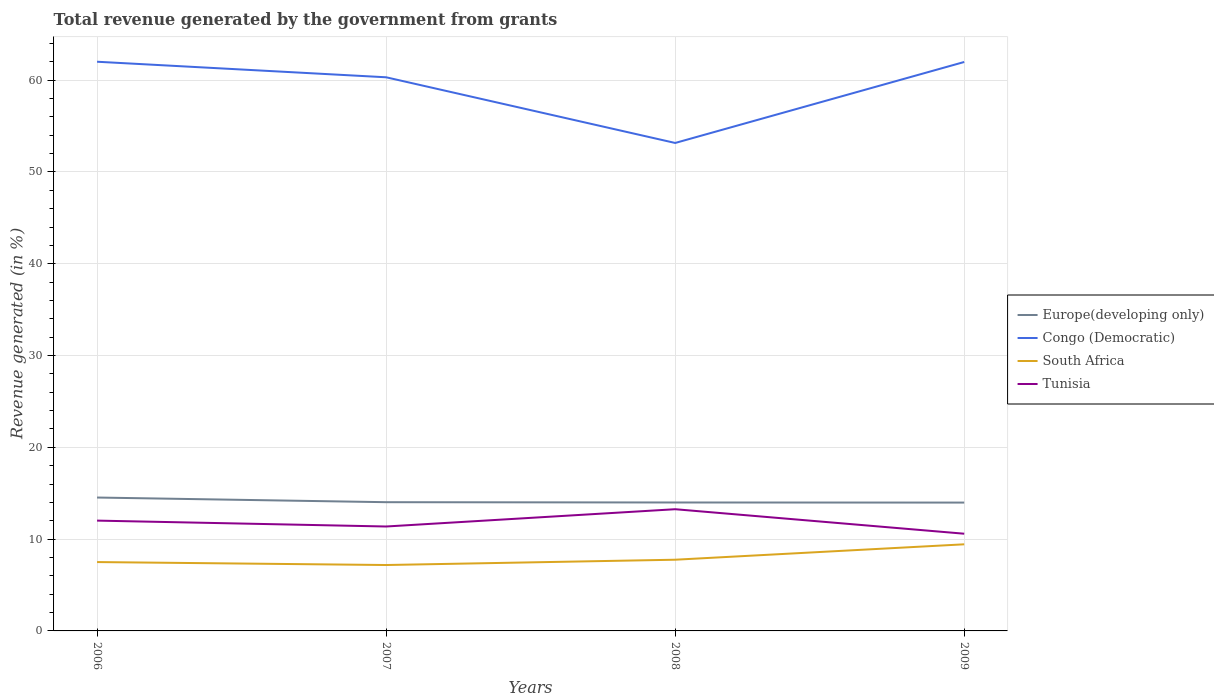How many different coloured lines are there?
Keep it short and to the point. 4. Does the line corresponding to Tunisia intersect with the line corresponding to South Africa?
Provide a succinct answer. No. Across all years, what is the maximum total revenue generated in Europe(developing only)?
Offer a terse response. 13.98. What is the total total revenue generated in South Africa in the graph?
Provide a short and direct response. -1.68. What is the difference between the highest and the second highest total revenue generated in Congo (Democratic)?
Offer a terse response. 8.85. What is the difference between the highest and the lowest total revenue generated in Europe(developing only)?
Give a very brief answer. 1. Is the total revenue generated in Tunisia strictly greater than the total revenue generated in Congo (Democratic) over the years?
Ensure brevity in your answer.  Yes. Does the graph contain any zero values?
Ensure brevity in your answer.  No. How many legend labels are there?
Give a very brief answer. 4. How are the legend labels stacked?
Keep it short and to the point. Vertical. What is the title of the graph?
Offer a very short reply. Total revenue generated by the government from grants. Does "Georgia" appear as one of the legend labels in the graph?
Your answer should be compact. No. What is the label or title of the X-axis?
Your answer should be compact. Years. What is the label or title of the Y-axis?
Provide a short and direct response. Revenue generated (in %). What is the Revenue generated (in %) of Europe(developing only) in 2006?
Your answer should be very brief. 14.53. What is the Revenue generated (in %) of Congo (Democratic) in 2006?
Offer a very short reply. 62.01. What is the Revenue generated (in %) of South Africa in 2006?
Make the answer very short. 7.5. What is the Revenue generated (in %) of Tunisia in 2006?
Make the answer very short. 12.02. What is the Revenue generated (in %) in Europe(developing only) in 2007?
Ensure brevity in your answer.  14.02. What is the Revenue generated (in %) in Congo (Democratic) in 2007?
Make the answer very short. 60.31. What is the Revenue generated (in %) of South Africa in 2007?
Your answer should be compact. 7.18. What is the Revenue generated (in %) in Tunisia in 2007?
Make the answer very short. 11.38. What is the Revenue generated (in %) in Europe(developing only) in 2008?
Your answer should be very brief. 13.99. What is the Revenue generated (in %) in Congo (Democratic) in 2008?
Offer a terse response. 53.16. What is the Revenue generated (in %) of South Africa in 2008?
Provide a short and direct response. 7.76. What is the Revenue generated (in %) of Tunisia in 2008?
Provide a succinct answer. 13.26. What is the Revenue generated (in %) of Europe(developing only) in 2009?
Provide a succinct answer. 13.98. What is the Revenue generated (in %) in Congo (Democratic) in 2009?
Provide a short and direct response. 61.98. What is the Revenue generated (in %) of South Africa in 2009?
Make the answer very short. 9.44. What is the Revenue generated (in %) of Tunisia in 2009?
Ensure brevity in your answer.  10.59. Across all years, what is the maximum Revenue generated (in %) in Europe(developing only)?
Provide a short and direct response. 14.53. Across all years, what is the maximum Revenue generated (in %) of Congo (Democratic)?
Provide a succinct answer. 62.01. Across all years, what is the maximum Revenue generated (in %) in South Africa?
Provide a short and direct response. 9.44. Across all years, what is the maximum Revenue generated (in %) in Tunisia?
Your answer should be very brief. 13.26. Across all years, what is the minimum Revenue generated (in %) in Europe(developing only)?
Ensure brevity in your answer.  13.98. Across all years, what is the minimum Revenue generated (in %) of Congo (Democratic)?
Keep it short and to the point. 53.16. Across all years, what is the minimum Revenue generated (in %) of South Africa?
Offer a terse response. 7.18. Across all years, what is the minimum Revenue generated (in %) of Tunisia?
Provide a short and direct response. 10.59. What is the total Revenue generated (in %) of Europe(developing only) in the graph?
Your answer should be compact. 56.53. What is the total Revenue generated (in %) of Congo (Democratic) in the graph?
Your answer should be compact. 237.45. What is the total Revenue generated (in %) in South Africa in the graph?
Provide a succinct answer. 31.87. What is the total Revenue generated (in %) in Tunisia in the graph?
Offer a very short reply. 47.24. What is the difference between the Revenue generated (in %) in Europe(developing only) in 2006 and that in 2007?
Ensure brevity in your answer.  0.51. What is the difference between the Revenue generated (in %) in Congo (Democratic) in 2006 and that in 2007?
Make the answer very short. 1.69. What is the difference between the Revenue generated (in %) of South Africa in 2006 and that in 2007?
Offer a terse response. 0.32. What is the difference between the Revenue generated (in %) in Tunisia in 2006 and that in 2007?
Your answer should be very brief. 0.64. What is the difference between the Revenue generated (in %) in Europe(developing only) in 2006 and that in 2008?
Offer a very short reply. 0.54. What is the difference between the Revenue generated (in %) of Congo (Democratic) in 2006 and that in 2008?
Ensure brevity in your answer.  8.85. What is the difference between the Revenue generated (in %) of South Africa in 2006 and that in 2008?
Ensure brevity in your answer.  -0.25. What is the difference between the Revenue generated (in %) in Tunisia in 2006 and that in 2008?
Offer a terse response. -1.24. What is the difference between the Revenue generated (in %) of Europe(developing only) in 2006 and that in 2009?
Your answer should be compact. 0.55. What is the difference between the Revenue generated (in %) of Congo (Democratic) in 2006 and that in 2009?
Your answer should be compact. 0.03. What is the difference between the Revenue generated (in %) of South Africa in 2006 and that in 2009?
Your answer should be very brief. -1.93. What is the difference between the Revenue generated (in %) of Tunisia in 2006 and that in 2009?
Offer a terse response. 1.43. What is the difference between the Revenue generated (in %) of Europe(developing only) in 2007 and that in 2008?
Ensure brevity in your answer.  0.03. What is the difference between the Revenue generated (in %) of Congo (Democratic) in 2007 and that in 2008?
Offer a terse response. 7.16. What is the difference between the Revenue generated (in %) of South Africa in 2007 and that in 2008?
Provide a short and direct response. -0.58. What is the difference between the Revenue generated (in %) of Tunisia in 2007 and that in 2008?
Make the answer very short. -1.88. What is the difference between the Revenue generated (in %) in Europe(developing only) in 2007 and that in 2009?
Provide a short and direct response. 0.04. What is the difference between the Revenue generated (in %) of Congo (Democratic) in 2007 and that in 2009?
Your answer should be very brief. -1.67. What is the difference between the Revenue generated (in %) of South Africa in 2007 and that in 2009?
Offer a terse response. -2.26. What is the difference between the Revenue generated (in %) in Tunisia in 2007 and that in 2009?
Give a very brief answer. 0.79. What is the difference between the Revenue generated (in %) in Europe(developing only) in 2008 and that in 2009?
Ensure brevity in your answer.  0.01. What is the difference between the Revenue generated (in %) of Congo (Democratic) in 2008 and that in 2009?
Offer a terse response. -8.82. What is the difference between the Revenue generated (in %) in South Africa in 2008 and that in 2009?
Your response must be concise. -1.68. What is the difference between the Revenue generated (in %) in Tunisia in 2008 and that in 2009?
Your response must be concise. 2.67. What is the difference between the Revenue generated (in %) of Europe(developing only) in 2006 and the Revenue generated (in %) of Congo (Democratic) in 2007?
Your answer should be very brief. -45.78. What is the difference between the Revenue generated (in %) of Europe(developing only) in 2006 and the Revenue generated (in %) of South Africa in 2007?
Offer a terse response. 7.35. What is the difference between the Revenue generated (in %) of Europe(developing only) in 2006 and the Revenue generated (in %) of Tunisia in 2007?
Your answer should be very brief. 3.16. What is the difference between the Revenue generated (in %) of Congo (Democratic) in 2006 and the Revenue generated (in %) of South Africa in 2007?
Keep it short and to the point. 54.83. What is the difference between the Revenue generated (in %) of Congo (Democratic) in 2006 and the Revenue generated (in %) of Tunisia in 2007?
Provide a short and direct response. 50.63. What is the difference between the Revenue generated (in %) of South Africa in 2006 and the Revenue generated (in %) of Tunisia in 2007?
Make the answer very short. -3.87. What is the difference between the Revenue generated (in %) in Europe(developing only) in 2006 and the Revenue generated (in %) in Congo (Democratic) in 2008?
Your response must be concise. -38.63. What is the difference between the Revenue generated (in %) in Europe(developing only) in 2006 and the Revenue generated (in %) in South Africa in 2008?
Ensure brevity in your answer.  6.78. What is the difference between the Revenue generated (in %) in Europe(developing only) in 2006 and the Revenue generated (in %) in Tunisia in 2008?
Your response must be concise. 1.27. What is the difference between the Revenue generated (in %) in Congo (Democratic) in 2006 and the Revenue generated (in %) in South Africa in 2008?
Provide a succinct answer. 54.25. What is the difference between the Revenue generated (in %) in Congo (Democratic) in 2006 and the Revenue generated (in %) in Tunisia in 2008?
Offer a very short reply. 48.75. What is the difference between the Revenue generated (in %) of South Africa in 2006 and the Revenue generated (in %) of Tunisia in 2008?
Keep it short and to the point. -5.76. What is the difference between the Revenue generated (in %) of Europe(developing only) in 2006 and the Revenue generated (in %) of Congo (Democratic) in 2009?
Offer a very short reply. -47.45. What is the difference between the Revenue generated (in %) of Europe(developing only) in 2006 and the Revenue generated (in %) of South Africa in 2009?
Offer a very short reply. 5.1. What is the difference between the Revenue generated (in %) in Europe(developing only) in 2006 and the Revenue generated (in %) in Tunisia in 2009?
Keep it short and to the point. 3.94. What is the difference between the Revenue generated (in %) of Congo (Democratic) in 2006 and the Revenue generated (in %) of South Africa in 2009?
Offer a very short reply. 52.57. What is the difference between the Revenue generated (in %) of Congo (Democratic) in 2006 and the Revenue generated (in %) of Tunisia in 2009?
Your answer should be compact. 51.42. What is the difference between the Revenue generated (in %) in South Africa in 2006 and the Revenue generated (in %) in Tunisia in 2009?
Your response must be concise. -3.09. What is the difference between the Revenue generated (in %) in Europe(developing only) in 2007 and the Revenue generated (in %) in Congo (Democratic) in 2008?
Your response must be concise. -39.13. What is the difference between the Revenue generated (in %) of Europe(developing only) in 2007 and the Revenue generated (in %) of South Africa in 2008?
Ensure brevity in your answer.  6.27. What is the difference between the Revenue generated (in %) of Europe(developing only) in 2007 and the Revenue generated (in %) of Tunisia in 2008?
Offer a very short reply. 0.77. What is the difference between the Revenue generated (in %) in Congo (Democratic) in 2007 and the Revenue generated (in %) in South Africa in 2008?
Ensure brevity in your answer.  52.56. What is the difference between the Revenue generated (in %) of Congo (Democratic) in 2007 and the Revenue generated (in %) of Tunisia in 2008?
Offer a terse response. 47.05. What is the difference between the Revenue generated (in %) of South Africa in 2007 and the Revenue generated (in %) of Tunisia in 2008?
Give a very brief answer. -6.08. What is the difference between the Revenue generated (in %) in Europe(developing only) in 2007 and the Revenue generated (in %) in Congo (Democratic) in 2009?
Provide a short and direct response. -47.95. What is the difference between the Revenue generated (in %) of Europe(developing only) in 2007 and the Revenue generated (in %) of South Africa in 2009?
Offer a terse response. 4.59. What is the difference between the Revenue generated (in %) in Europe(developing only) in 2007 and the Revenue generated (in %) in Tunisia in 2009?
Give a very brief answer. 3.43. What is the difference between the Revenue generated (in %) of Congo (Democratic) in 2007 and the Revenue generated (in %) of South Africa in 2009?
Keep it short and to the point. 50.88. What is the difference between the Revenue generated (in %) in Congo (Democratic) in 2007 and the Revenue generated (in %) in Tunisia in 2009?
Give a very brief answer. 49.72. What is the difference between the Revenue generated (in %) in South Africa in 2007 and the Revenue generated (in %) in Tunisia in 2009?
Your answer should be compact. -3.41. What is the difference between the Revenue generated (in %) in Europe(developing only) in 2008 and the Revenue generated (in %) in Congo (Democratic) in 2009?
Keep it short and to the point. -47.99. What is the difference between the Revenue generated (in %) of Europe(developing only) in 2008 and the Revenue generated (in %) of South Africa in 2009?
Provide a succinct answer. 4.56. What is the difference between the Revenue generated (in %) in Europe(developing only) in 2008 and the Revenue generated (in %) in Tunisia in 2009?
Keep it short and to the point. 3.4. What is the difference between the Revenue generated (in %) in Congo (Democratic) in 2008 and the Revenue generated (in %) in South Africa in 2009?
Keep it short and to the point. 43.72. What is the difference between the Revenue generated (in %) in Congo (Democratic) in 2008 and the Revenue generated (in %) in Tunisia in 2009?
Give a very brief answer. 42.57. What is the difference between the Revenue generated (in %) in South Africa in 2008 and the Revenue generated (in %) in Tunisia in 2009?
Ensure brevity in your answer.  -2.83. What is the average Revenue generated (in %) of Europe(developing only) per year?
Offer a very short reply. 14.13. What is the average Revenue generated (in %) in Congo (Democratic) per year?
Keep it short and to the point. 59.36. What is the average Revenue generated (in %) in South Africa per year?
Make the answer very short. 7.97. What is the average Revenue generated (in %) of Tunisia per year?
Offer a terse response. 11.81. In the year 2006, what is the difference between the Revenue generated (in %) in Europe(developing only) and Revenue generated (in %) in Congo (Democratic)?
Your answer should be compact. -47.47. In the year 2006, what is the difference between the Revenue generated (in %) of Europe(developing only) and Revenue generated (in %) of South Africa?
Your response must be concise. 7.03. In the year 2006, what is the difference between the Revenue generated (in %) of Europe(developing only) and Revenue generated (in %) of Tunisia?
Your response must be concise. 2.51. In the year 2006, what is the difference between the Revenue generated (in %) of Congo (Democratic) and Revenue generated (in %) of South Africa?
Offer a very short reply. 54.5. In the year 2006, what is the difference between the Revenue generated (in %) of Congo (Democratic) and Revenue generated (in %) of Tunisia?
Keep it short and to the point. 49.99. In the year 2006, what is the difference between the Revenue generated (in %) of South Africa and Revenue generated (in %) of Tunisia?
Your answer should be compact. -4.52. In the year 2007, what is the difference between the Revenue generated (in %) of Europe(developing only) and Revenue generated (in %) of Congo (Democratic)?
Your response must be concise. -46.29. In the year 2007, what is the difference between the Revenue generated (in %) in Europe(developing only) and Revenue generated (in %) in South Africa?
Offer a very short reply. 6.84. In the year 2007, what is the difference between the Revenue generated (in %) in Europe(developing only) and Revenue generated (in %) in Tunisia?
Offer a terse response. 2.65. In the year 2007, what is the difference between the Revenue generated (in %) of Congo (Democratic) and Revenue generated (in %) of South Africa?
Provide a succinct answer. 53.13. In the year 2007, what is the difference between the Revenue generated (in %) in Congo (Democratic) and Revenue generated (in %) in Tunisia?
Provide a succinct answer. 48.94. In the year 2007, what is the difference between the Revenue generated (in %) of South Africa and Revenue generated (in %) of Tunisia?
Keep it short and to the point. -4.2. In the year 2008, what is the difference between the Revenue generated (in %) of Europe(developing only) and Revenue generated (in %) of Congo (Democratic)?
Offer a terse response. -39.16. In the year 2008, what is the difference between the Revenue generated (in %) of Europe(developing only) and Revenue generated (in %) of South Africa?
Ensure brevity in your answer.  6.24. In the year 2008, what is the difference between the Revenue generated (in %) in Europe(developing only) and Revenue generated (in %) in Tunisia?
Offer a very short reply. 0.73. In the year 2008, what is the difference between the Revenue generated (in %) in Congo (Democratic) and Revenue generated (in %) in South Africa?
Offer a terse response. 45.4. In the year 2008, what is the difference between the Revenue generated (in %) in Congo (Democratic) and Revenue generated (in %) in Tunisia?
Give a very brief answer. 39.9. In the year 2008, what is the difference between the Revenue generated (in %) of South Africa and Revenue generated (in %) of Tunisia?
Ensure brevity in your answer.  -5.5. In the year 2009, what is the difference between the Revenue generated (in %) in Europe(developing only) and Revenue generated (in %) in Congo (Democratic)?
Give a very brief answer. -48. In the year 2009, what is the difference between the Revenue generated (in %) of Europe(developing only) and Revenue generated (in %) of South Africa?
Your response must be concise. 4.55. In the year 2009, what is the difference between the Revenue generated (in %) in Europe(developing only) and Revenue generated (in %) in Tunisia?
Provide a succinct answer. 3.39. In the year 2009, what is the difference between the Revenue generated (in %) of Congo (Democratic) and Revenue generated (in %) of South Africa?
Give a very brief answer. 52.54. In the year 2009, what is the difference between the Revenue generated (in %) of Congo (Democratic) and Revenue generated (in %) of Tunisia?
Provide a succinct answer. 51.39. In the year 2009, what is the difference between the Revenue generated (in %) in South Africa and Revenue generated (in %) in Tunisia?
Give a very brief answer. -1.15. What is the ratio of the Revenue generated (in %) in Europe(developing only) in 2006 to that in 2007?
Offer a very short reply. 1.04. What is the ratio of the Revenue generated (in %) in Congo (Democratic) in 2006 to that in 2007?
Make the answer very short. 1.03. What is the ratio of the Revenue generated (in %) of South Africa in 2006 to that in 2007?
Make the answer very short. 1.04. What is the ratio of the Revenue generated (in %) in Tunisia in 2006 to that in 2007?
Your response must be concise. 1.06. What is the ratio of the Revenue generated (in %) of Congo (Democratic) in 2006 to that in 2008?
Your answer should be compact. 1.17. What is the ratio of the Revenue generated (in %) in South Africa in 2006 to that in 2008?
Ensure brevity in your answer.  0.97. What is the ratio of the Revenue generated (in %) in Tunisia in 2006 to that in 2008?
Ensure brevity in your answer.  0.91. What is the ratio of the Revenue generated (in %) in Europe(developing only) in 2006 to that in 2009?
Your answer should be very brief. 1.04. What is the ratio of the Revenue generated (in %) in South Africa in 2006 to that in 2009?
Your answer should be very brief. 0.8. What is the ratio of the Revenue generated (in %) of Tunisia in 2006 to that in 2009?
Give a very brief answer. 1.13. What is the ratio of the Revenue generated (in %) in Congo (Democratic) in 2007 to that in 2008?
Give a very brief answer. 1.13. What is the ratio of the Revenue generated (in %) in South Africa in 2007 to that in 2008?
Keep it short and to the point. 0.93. What is the ratio of the Revenue generated (in %) in Tunisia in 2007 to that in 2008?
Offer a very short reply. 0.86. What is the ratio of the Revenue generated (in %) of Congo (Democratic) in 2007 to that in 2009?
Your answer should be very brief. 0.97. What is the ratio of the Revenue generated (in %) in South Africa in 2007 to that in 2009?
Ensure brevity in your answer.  0.76. What is the ratio of the Revenue generated (in %) of Tunisia in 2007 to that in 2009?
Your answer should be very brief. 1.07. What is the ratio of the Revenue generated (in %) in Congo (Democratic) in 2008 to that in 2009?
Make the answer very short. 0.86. What is the ratio of the Revenue generated (in %) of South Africa in 2008 to that in 2009?
Your answer should be compact. 0.82. What is the ratio of the Revenue generated (in %) in Tunisia in 2008 to that in 2009?
Make the answer very short. 1.25. What is the difference between the highest and the second highest Revenue generated (in %) in Europe(developing only)?
Your answer should be compact. 0.51. What is the difference between the highest and the second highest Revenue generated (in %) of Congo (Democratic)?
Offer a very short reply. 0.03. What is the difference between the highest and the second highest Revenue generated (in %) of South Africa?
Your answer should be very brief. 1.68. What is the difference between the highest and the second highest Revenue generated (in %) in Tunisia?
Offer a very short reply. 1.24. What is the difference between the highest and the lowest Revenue generated (in %) in Europe(developing only)?
Keep it short and to the point. 0.55. What is the difference between the highest and the lowest Revenue generated (in %) in Congo (Democratic)?
Give a very brief answer. 8.85. What is the difference between the highest and the lowest Revenue generated (in %) in South Africa?
Provide a succinct answer. 2.26. What is the difference between the highest and the lowest Revenue generated (in %) in Tunisia?
Provide a succinct answer. 2.67. 